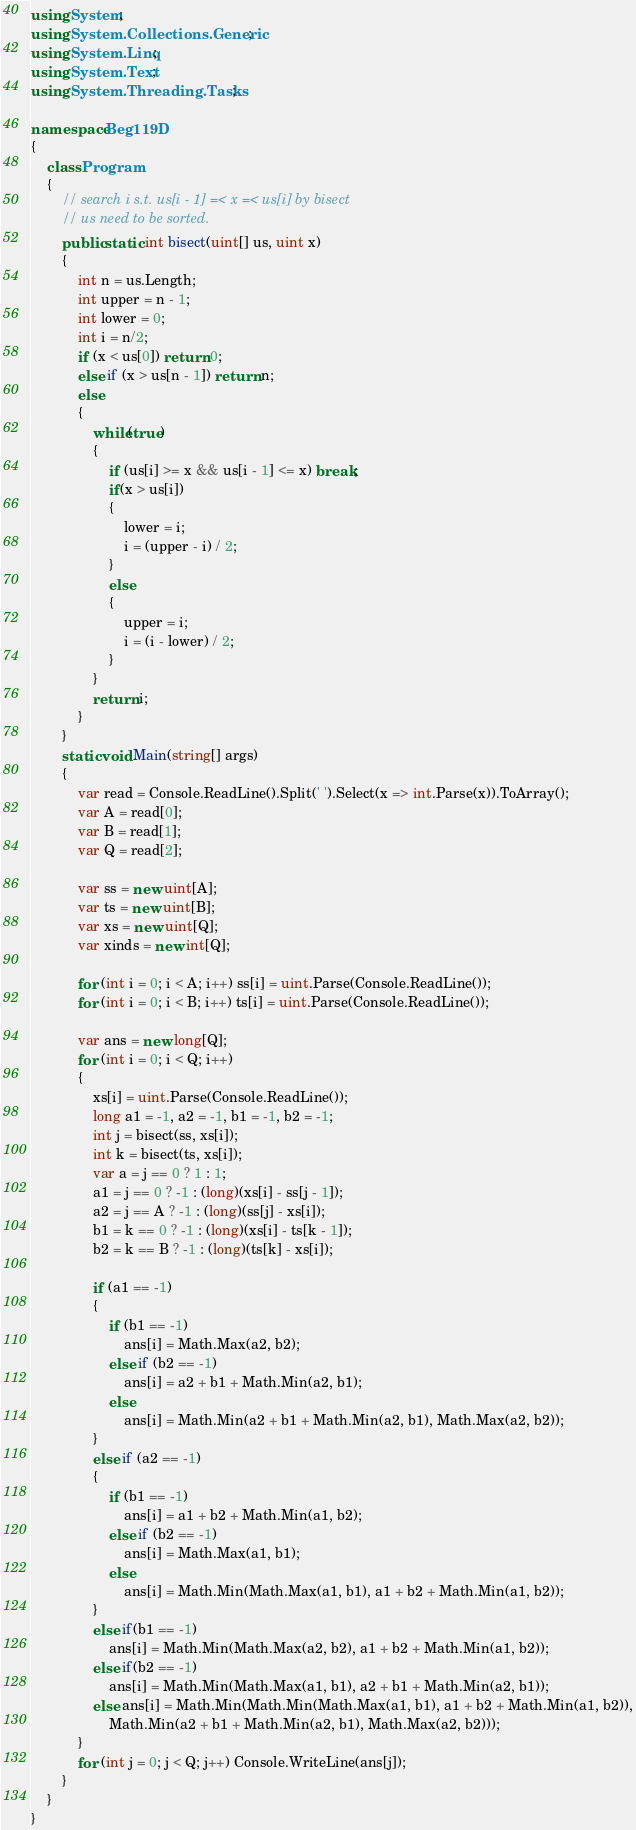<code> <loc_0><loc_0><loc_500><loc_500><_C#_>using System;
using System.Collections.Generic;
using System.Linq;
using System.Text;
using System.Threading.Tasks;

namespace Beg119D
{
    class Program
    {
        // search i s.t. us[i - 1] =< x =< us[i] by bisect
        // us need to be sorted.
        public static int bisect(uint[] us, uint x)
        {
            int n = us.Length;
            int upper = n - 1;
            int lower = 0;
            int i = n/2;
            if (x < us[0]) return 0;
            else if (x > us[n - 1]) return n;
            else
            {
                while(true)
                {
                    if (us[i] >= x && us[i - 1] <= x) break;
                    if(x > us[i])
                    {
                        lower = i;
                        i = (upper - i) / 2;
                    }
                    else
                    {
                        upper = i;
                        i = (i - lower) / 2;
                    }
                }
                return i;
            }
        }
        static void Main(string[] args)
        {
            var read = Console.ReadLine().Split(' ').Select(x => int.Parse(x)).ToArray();
            var A = read[0];
            var B = read[1];
            var Q = read[2];

            var ss = new uint[A];
            var ts = new uint[B];
            var xs = new uint[Q];
            var xinds = new int[Q];

            for (int i = 0; i < A; i++) ss[i] = uint.Parse(Console.ReadLine());
            for (int i = 0; i < B; i++) ts[i] = uint.Parse(Console.ReadLine());

            var ans = new long[Q];
            for (int i = 0; i < Q; i++)
            {
                xs[i] = uint.Parse(Console.ReadLine());
                long a1 = -1, a2 = -1, b1 = -1, b2 = -1; 
                int j = bisect(ss, xs[i]);
                int k = bisect(ts, xs[i]);
                var a = j == 0 ? 1 : 1;
                a1 = j == 0 ? -1 : (long)(xs[i] - ss[j - 1]);
                a2 = j == A ? -1 : (long)(ss[j] - xs[i]);
                b1 = k == 0 ? -1 : (long)(xs[i] - ts[k - 1]);
                b2 = k == B ? -1 : (long)(ts[k] - xs[i]);

                if (a1 == -1)
                {
                    if (b1 == -1)
                        ans[i] = Math.Max(a2, b2);
                    else if (b2 == -1)
                        ans[i] = a2 + b1 + Math.Min(a2, b1);
                    else
                        ans[i] = Math.Min(a2 + b1 + Math.Min(a2, b1), Math.Max(a2, b2));
                }
                else if (a2 == -1)
                {
                    if (b1 == -1)
                        ans[i] = a1 + b2 + Math.Min(a1, b2);
                    else if (b2 == -1)
                        ans[i] = Math.Max(a1, b1);
                    else
                        ans[i] = Math.Min(Math.Max(a1, b1), a1 + b2 + Math.Min(a1, b2));
                }
                else if(b1 == -1)
                    ans[i] = Math.Min(Math.Max(a2, b2), a1 + b2 + Math.Min(a1, b2));
                else if(b2 == -1)
                    ans[i] = Math.Min(Math.Max(a1, b1), a2 + b1 + Math.Min(a2, b1));
                else ans[i] = Math.Min(Math.Min(Math.Max(a1, b1), a1 + b2 + Math.Min(a1, b2)),
                    Math.Min(a2 + b1 + Math.Min(a2, b1), Math.Max(a2, b2)));
            }
            for (int j = 0; j < Q; j++) Console.WriteLine(ans[j]);
        }
    }
}
</code> 